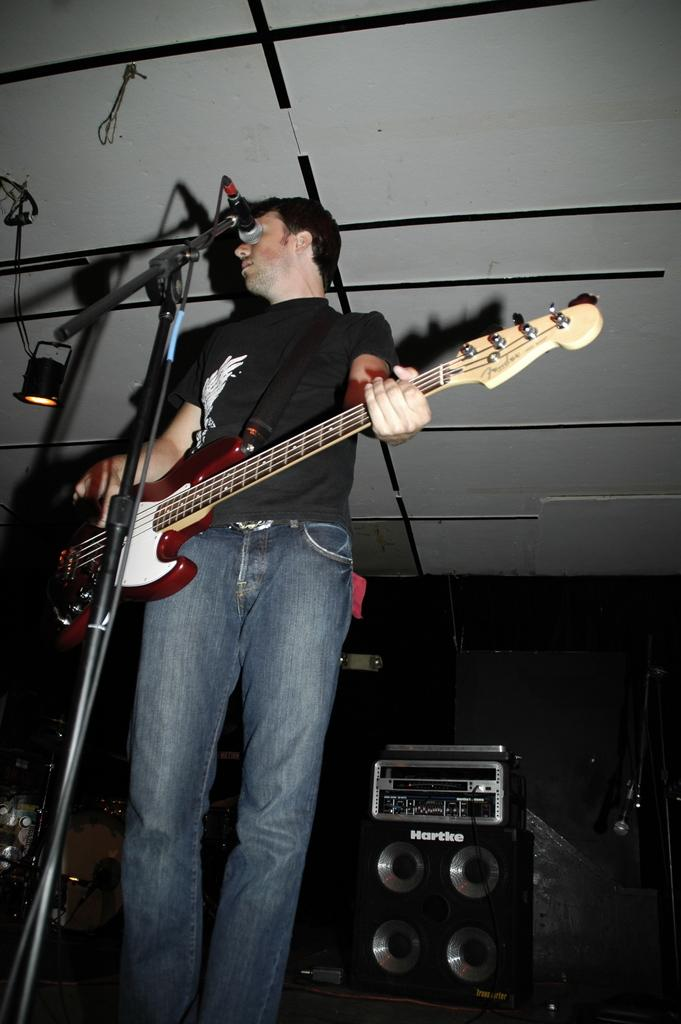What is the man in the image doing? The man is playing the guitar in the image. What object is the man holding in his hand? The man is holding a guitar in his hand. What is in front of the man? There is a microphone in front of the man. What can be seen in the background of the image? In the background of the image, there are speakers, a wall, and a light. How many chairs can be seen in the image? There are no chairs visible in the image. What color is the orange in the image? There is no orange present in the image. 